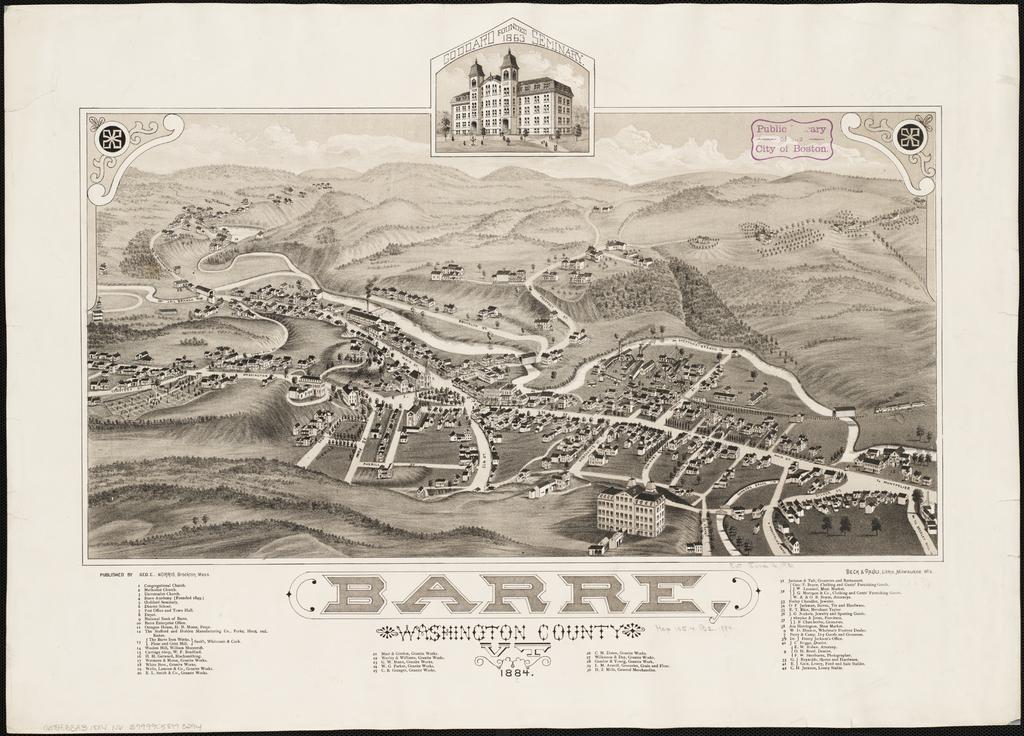How hold is the map?
Offer a very short reply. 1884. What is this a map of?
Make the answer very short. Barre. 